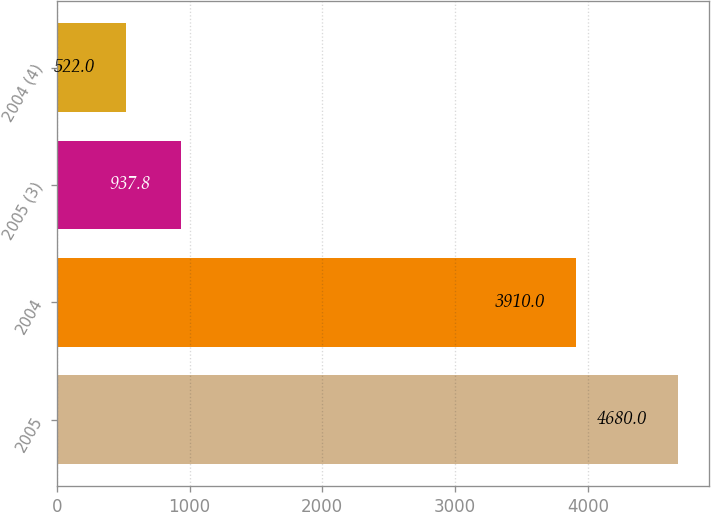<chart> <loc_0><loc_0><loc_500><loc_500><bar_chart><fcel>2005<fcel>2004<fcel>2005 (3)<fcel>2004 (4)<nl><fcel>4680<fcel>3910<fcel>937.8<fcel>522<nl></chart> 